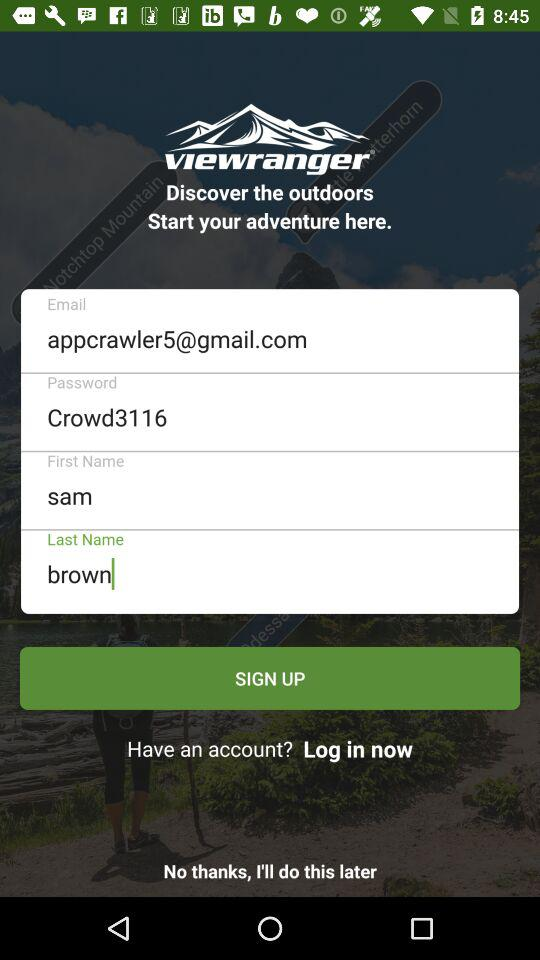What is the first name? The first name is Sam. 